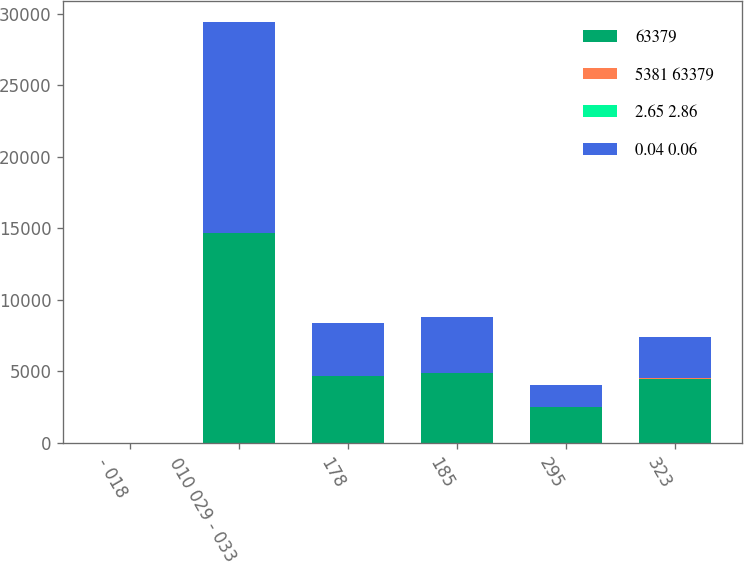Convert chart to OTSL. <chart><loc_0><loc_0><loc_500><loc_500><stacked_bar_chart><ecel><fcel>- 018<fcel>010 029 - 033<fcel>178<fcel>185<fcel>295<fcel>323<nl><fcel>63379<fcel>6.73<fcel>14701<fcel>4693<fcel>4865<fcel>2506<fcel>4500<nl><fcel>5381 63379<fcel>3.66<fcel>4.4<fcel>5.59<fcel>6.04<fcel>6.64<fcel>6.82<nl><fcel>2.65 2.86<fcel>0.15<fcel>0.31<fcel>1.78<fcel>1.85<fcel>2.95<fcel>3.23<nl><fcel>0.04 0.06<fcel>6.73<fcel>14701<fcel>3701<fcel>3938<fcel>1567<fcel>2925<nl></chart> 